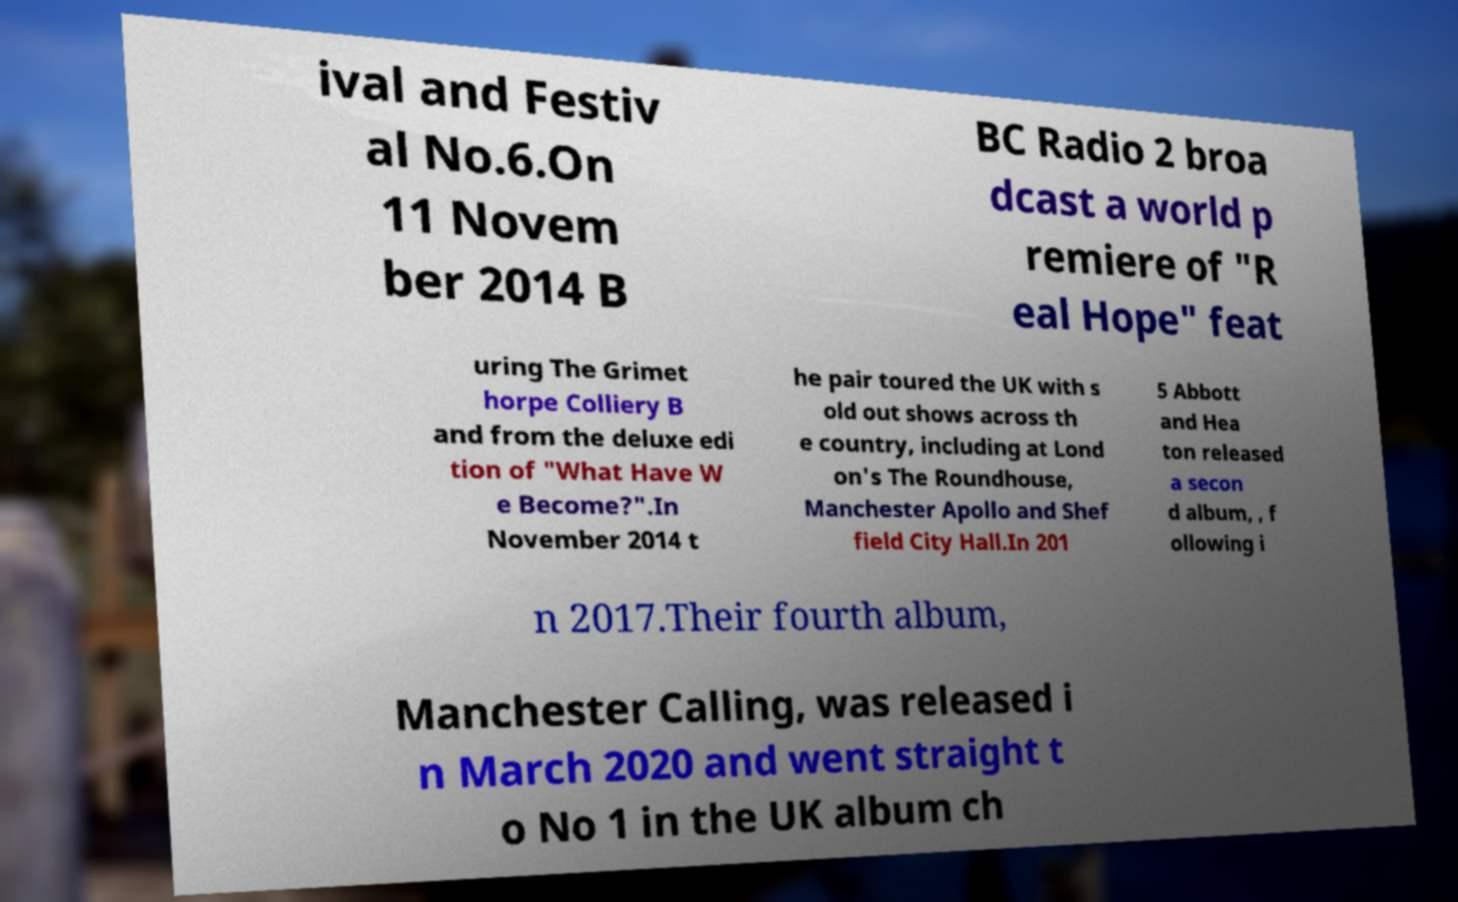I need the written content from this picture converted into text. Can you do that? ival and Festiv al No.6.On 11 Novem ber 2014 B BC Radio 2 broa dcast a world p remiere of "R eal Hope" feat uring The Grimet horpe Colliery B and from the deluxe edi tion of "What Have W e Become?".In November 2014 t he pair toured the UK with s old out shows across th e country, including at Lond on's The Roundhouse, Manchester Apollo and Shef field City Hall.In 201 5 Abbott and Hea ton released a secon d album, , f ollowing i n 2017.Their fourth album, Manchester Calling, was released i n March 2020 and went straight t o No 1 in the UK album ch 